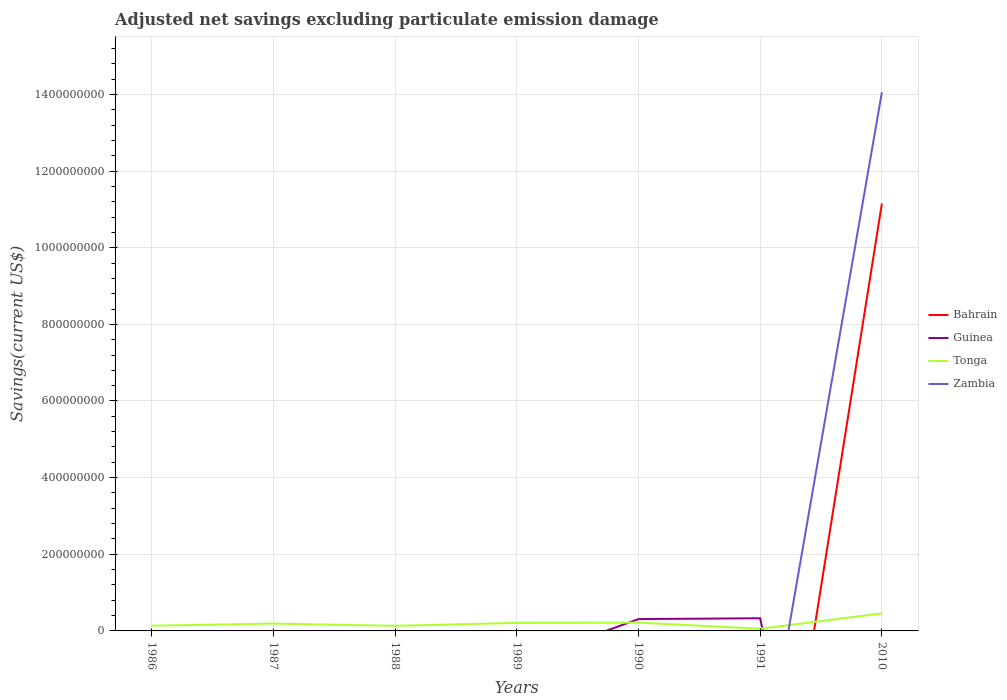Does the line corresponding to Guinea intersect with the line corresponding to Zambia?
Provide a short and direct response. Yes. Is the number of lines equal to the number of legend labels?
Provide a short and direct response. No. Across all years, what is the maximum adjusted net savings in Zambia?
Provide a short and direct response. 0. What is the total adjusted net savings in Tonga in the graph?
Ensure brevity in your answer.  -1.75e+06. What is the difference between the highest and the second highest adjusted net savings in Bahrain?
Offer a very short reply. 1.12e+09. Is the adjusted net savings in Bahrain strictly greater than the adjusted net savings in Tonga over the years?
Give a very brief answer. No. How many lines are there?
Offer a terse response. 4. Are the values on the major ticks of Y-axis written in scientific E-notation?
Provide a succinct answer. No. Does the graph contain any zero values?
Provide a short and direct response. Yes. What is the title of the graph?
Offer a terse response. Adjusted net savings excluding particulate emission damage. What is the label or title of the X-axis?
Your answer should be very brief. Years. What is the label or title of the Y-axis?
Make the answer very short. Savings(current US$). What is the Savings(current US$) in Bahrain in 1986?
Provide a short and direct response. 0. What is the Savings(current US$) in Guinea in 1986?
Keep it short and to the point. 0. What is the Savings(current US$) in Tonga in 1986?
Your answer should be very brief. 1.37e+07. What is the Savings(current US$) of Zambia in 1986?
Offer a terse response. 0. What is the Savings(current US$) of Tonga in 1987?
Make the answer very short. 1.92e+07. What is the Savings(current US$) in Tonga in 1988?
Offer a terse response. 1.33e+07. What is the Savings(current US$) of Zambia in 1988?
Offer a very short reply. 0. What is the Savings(current US$) in Tonga in 1989?
Provide a short and direct response. 2.09e+07. What is the Savings(current US$) in Zambia in 1989?
Provide a succinct answer. 0. What is the Savings(current US$) in Guinea in 1990?
Offer a terse response. 3.09e+07. What is the Savings(current US$) of Tonga in 1990?
Offer a terse response. 2.17e+07. What is the Savings(current US$) of Zambia in 1990?
Ensure brevity in your answer.  0. What is the Savings(current US$) in Guinea in 1991?
Keep it short and to the point. 3.30e+07. What is the Savings(current US$) of Tonga in 1991?
Your answer should be compact. 5.70e+06. What is the Savings(current US$) in Bahrain in 2010?
Offer a very short reply. 1.12e+09. What is the Savings(current US$) of Tonga in 2010?
Your answer should be very brief. 4.58e+07. What is the Savings(current US$) in Zambia in 2010?
Your answer should be very brief. 1.41e+09. Across all years, what is the maximum Savings(current US$) in Bahrain?
Provide a succinct answer. 1.12e+09. Across all years, what is the maximum Savings(current US$) in Guinea?
Offer a very short reply. 3.30e+07. Across all years, what is the maximum Savings(current US$) of Tonga?
Offer a very short reply. 4.58e+07. Across all years, what is the maximum Savings(current US$) in Zambia?
Your answer should be very brief. 1.41e+09. Across all years, what is the minimum Savings(current US$) of Guinea?
Offer a terse response. 0. Across all years, what is the minimum Savings(current US$) of Tonga?
Ensure brevity in your answer.  5.70e+06. Across all years, what is the minimum Savings(current US$) in Zambia?
Make the answer very short. 0. What is the total Savings(current US$) in Bahrain in the graph?
Give a very brief answer. 1.12e+09. What is the total Savings(current US$) in Guinea in the graph?
Make the answer very short. 6.40e+07. What is the total Savings(current US$) in Tonga in the graph?
Provide a short and direct response. 1.40e+08. What is the total Savings(current US$) in Zambia in the graph?
Keep it short and to the point. 1.41e+09. What is the difference between the Savings(current US$) of Tonga in 1986 and that in 1987?
Ensure brevity in your answer.  -5.50e+06. What is the difference between the Savings(current US$) in Tonga in 1986 and that in 1988?
Give a very brief answer. 3.44e+05. What is the difference between the Savings(current US$) in Tonga in 1986 and that in 1989?
Your answer should be very brief. -7.25e+06. What is the difference between the Savings(current US$) of Tonga in 1986 and that in 1990?
Give a very brief answer. -7.97e+06. What is the difference between the Savings(current US$) of Tonga in 1986 and that in 1991?
Your answer should be compact. 7.98e+06. What is the difference between the Savings(current US$) of Tonga in 1986 and that in 2010?
Your response must be concise. -3.21e+07. What is the difference between the Savings(current US$) of Tonga in 1987 and that in 1988?
Your response must be concise. 5.84e+06. What is the difference between the Savings(current US$) in Tonga in 1987 and that in 1989?
Offer a very short reply. -1.75e+06. What is the difference between the Savings(current US$) of Tonga in 1987 and that in 1990?
Your answer should be compact. -2.47e+06. What is the difference between the Savings(current US$) of Tonga in 1987 and that in 1991?
Offer a very short reply. 1.35e+07. What is the difference between the Savings(current US$) in Tonga in 1987 and that in 2010?
Offer a terse response. -2.66e+07. What is the difference between the Savings(current US$) in Tonga in 1988 and that in 1989?
Make the answer very short. -7.59e+06. What is the difference between the Savings(current US$) of Tonga in 1988 and that in 1990?
Offer a very short reply. -8.31e+06. What is the difference between the Savings(current US$) of Tonga in 1988 and that in 1991?
Offer a very short reply. 7.64e+06. What is the difference between the Savings(current US$) of Tonga in 1988 and that in 2010?
Your response must be concise. -3.24e+07. What is the difference between the Savings(current US$) of Tonga in 1989 and that in 1990?
Provide a succinct answer. -7.25e+05. What is the difference between the Savings(current US$) of Tonga in 1989 and that in 1991?
Your response must be concise. 1.52e+07. What is the difference between the Savings(current US$) of Tonga in 1989 and that in 2010?
Make the answer very short. -2.49e+07. What is the difference between the Savings(current US$) in Guinea in 1990 and that in 1991?
Make the answer very short. -2.14e+06. What is the difference between the Savings(current US$) in Tonga in 1990 and that in 1991?
Offer a terse response. 1.60e+07. What is the difference between the Savings(current US$) of Tonga in 1990 and that in 2010?
Offer a terse response. -2.41e+07. What is the difference between the Savings(current US$) of Tonga in 1991 and that in 2010?
Offer a very short reply. -4.01e+07. What is the difference between the Savings(current US$) in Tonga in 1986 and the Savings(current US$) in Zambia in 2010?
Keep it short and to the point. -1.39e+09. What is the difference between the Savings(current US$) of Tonga in 1987 and the Savings(current US$) of Zambia in 2010?
Your answer should be very brief. -1.39e+09. What is the difference between the Savings(current US$) in Tonga in 1988 and the Savings(current US$) in Zambia in 2010?
Keep it short and to the point. -1.39e+09. What is the difference between the Savings(current US$) in Tonga in 1989 and the Savings(current US$) in Zambia in 2010?
Provide a short and direct response. -1.38e+09. What is the difference between the Savings(current US$) in Guinea in 1990 and the Savings(current US$) in Tonga in 1991?
Keep it short and to the point. 2.52e+07. What is the difference between the Savings(current US$) in Guinea in 1990 and the Savings(current US$) in Tonga in 2010?
Provide a short and direct response. -1.49e+07. What is the difference between the Savings(current US$) of Guinea in 1990 and the Savings(current US$) of Zambia in 2010?
Keep it short and to the point. -1.37e+09. What is the difference between the Savings(current US$) of Tonga in 1990 and the Savings(current US$) of Zambia in 2010?
Offer a very short reply. -1.38e+09. What is the difference between the Savings(current US$) in Guinea in 1991 and the Savings(current US$) in Tonga in 2010?
Make the answer very short. -1.27e+07. What is the difference between the Savings(current US$) of Guinea in 1991 and the Savings(current US$) of Zambia in 2010?
Ensure brevity in your answer.  -1.37e+09. What is the difference between the Savings(current US$) of Tonga in 1991 and the Savings(current US$) of Zambia in 2010?
Ensure brevity in your answer.  -1.40e+09. What is the average Savings(current US$) in Bahrain per year?
Give a very brief answer. 1.59e+08. What is the average Savings(current US$) of Guinea per year?
Give a very brief answer. 9.14e+06. What is the average Savings(current US$) in Tonga per year?
Make the answer very short. 2.00e+07. What is the average Savings(current US$) of Zambia per year?
Give a very brief answer. 2.01e+08. In the year 1990, what is the difference between the Savings(current US$) in Guinea and Savings(current US$) in Tonga?
Make the answer very short. 9.25e+06. In the year 1991, what is the difference between the Savings(current US$) in Guinea and Savings(current US$) in Tonga?
Ensure brevity in your answer.  2.73e+07. In the year 2010, what is the difference between the Savings(current US$) of Bahrain and Savings(current US$) of Tonga?
Your answer should be compact. 1.07e+09. In the year 2010, what is the difference between the Savings(current US$) of Bahrain and Savings(current US$) of Zambia?
Keep it short and to the point. -2.90e+08. In the year 2010, what is the difference between the Savings(current US$) in Tonga and Savings(current US$) in Zambia?
Keep it short and to the point. -1.36e+09. What is the ratio of the Savings(current US$) of Tonga in 1986 to that in 1987?
Ensure brevity in your answer.  0.71. What is the ratio of the Savings(current US$) in Tonga in 1986 to that in 1988?
Your answer should be very brief. 1.03. What is the ratio of the Savings(current US$) in Tonga in 1986 to that in 1989?
Your response must be concise. 0.65. What is the ratio of the Savings(current US$) in Tonga in 1986 to that in 1990?
Give a very brief answer. 0.63. What is the ratio of the Savings(current US$) in Tonga in 1986 to that in 1991?
Keep it short and to the point. 2.4. What is the ratio of the Savings(current US$) in Tonga in 1986 to that in 2010?
Make the answer very short. 0.3. What is the ratio of the Savings(current US$) in Tonga in 1987 to that in 1988?
Make the answer very short. 1.44. What is the ratio of the Savings(current US$) in Tonga in 1987 to that in 1989?
Your answer should be compact. 0.92. What is the ratio of the Savings(current US$) of Tonga in 1987 to that in 1990?
Make the answer very short. 0.89. What is the ratio of the Savings(current US$) in Tonga in 1987 to that in 1991?
Offer a terse response. 3.36. What is the ratio of the Savings(current US$) of Tonga in 1987 to that in 2010?
Provide a short and direct response. 0.42. What is the ratio of the Savings(current US$) of Tonga in 1988 to that in 1989?
Your response must be concise. 0.64. What is the ratio of the Savings(current US$) in Tonga in 1988 to that in 1990?
Give a very brief answer. 0.62. What is the ratio of the Savings(current US$) in Tonga in 1988 to that in 1991?
Give a very brief answer. 2.34. What is the ratio of the Savings(current US$) of Tonga in 1988 to that in 2010?
Offer a very short reply. 0.29. What is the ratio of the Savings(current US$) of Tonga in 1989 to that in 1990?
Offer a very short reply. 0.97. What is the ratio of the Savings(current US$) in Tonga in 1989 to that in 1991?
Offer a terse response. 3.67. What is the ratio of the Savings(current US$) of Tonga in 1989 to that in 2010?
Provide a succinct answer. 0.46. What is the ratio of the Savings(current US$) in Guinea in 1990 to that in 1991?
Offer a terse response. 0.94. What is the ratio of the Savings(current US$) of Tonga in 1990 to that in 1991?
Provide a short and direct response. 3.8. What is the ratio of the Savings(current US$) in Tonga in 1990 to that in 2010?
Offer a very short reply. 0.47. What is the ratio of the Savings(current US$) in Tonga in 1991 to that in 2010?
Your answer should be very brief. 0.12. What is the difference between the highest and the second highest Savings(current US$) of Tonga?
Your answer should be very brief. 2.41e+07. What is the difference between the highest and the lowest Savings(current US$) in Bahrain?
Your answer should be very brief. 1.12e+09. What is the difference between the highest and the lowest Savings(current US$) in Guinea?
Your response must be concise. 3.30e+07. What is the difference between the highest and the lowest Savings(current US$) of Tonga?
Offer a very short reply. 4.01e+07. What is the difference between the highest and the lowest Savings(current US$) in Zambia?
Keep it short and to the point. 1.41e+09. 